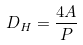Convert formula to latex. <formula><loc_0><loc_0><loc_500><loc_500>D _ { H } = \frac { 4 A } { P }</formula> 